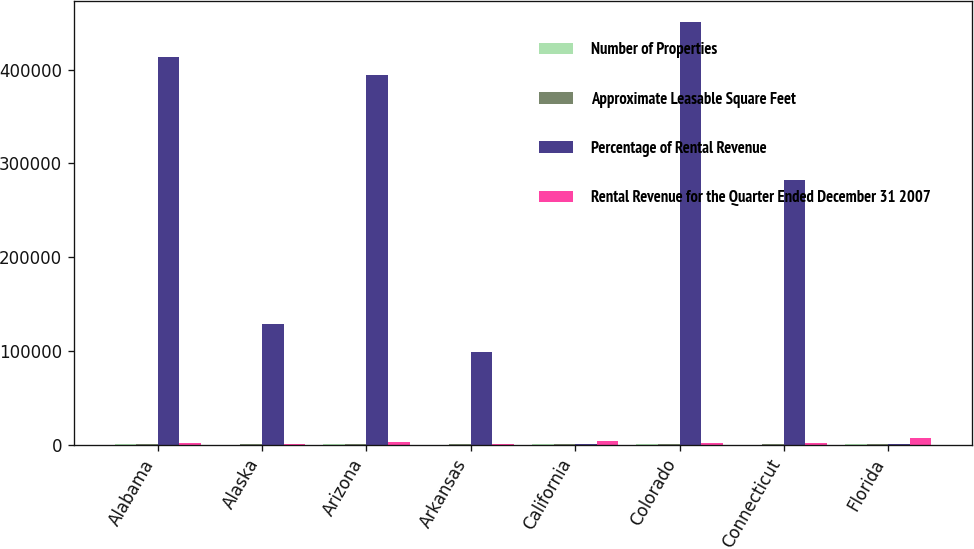Convert chart to OTSL. <chart><loc_0><loc_0><loc_500><loc_500><stacked_bar_chart><ecel><fcel>Alabama<fcel>Alaska<fcel>Arizona<fcel>Arkansas<fcel>California<fcel>Colorado<fcel>Connecticut<fcel>Florida<nl><fcel>Number of Properties<fcel>61<fcel>2<fcel>79<fcel>18<fcel>63<fcel>54<fcel>26<fcel>168<nl><fcel>Approximate Leasable Square Feet<fcel>98<fcel>100<fcel>99<fcel>100<fcel>98<fcel>98<fcel>100<fcel>98<nl><fcel>Percentage of Rental Revenue<fcel>413700<fcel>128500<fcel>394100<fcel>98500<fcel>134<fcel>451000<fcel>282300<fcel>134<nl><fcel>Rental Revenue for the Quarter Ended December 31 2007<fcel>1885<fcel>277<fcel>2426<fcel>436<fcel>4072<fcel>1943<fcel>1324<fcel>6706<nl></chart> 